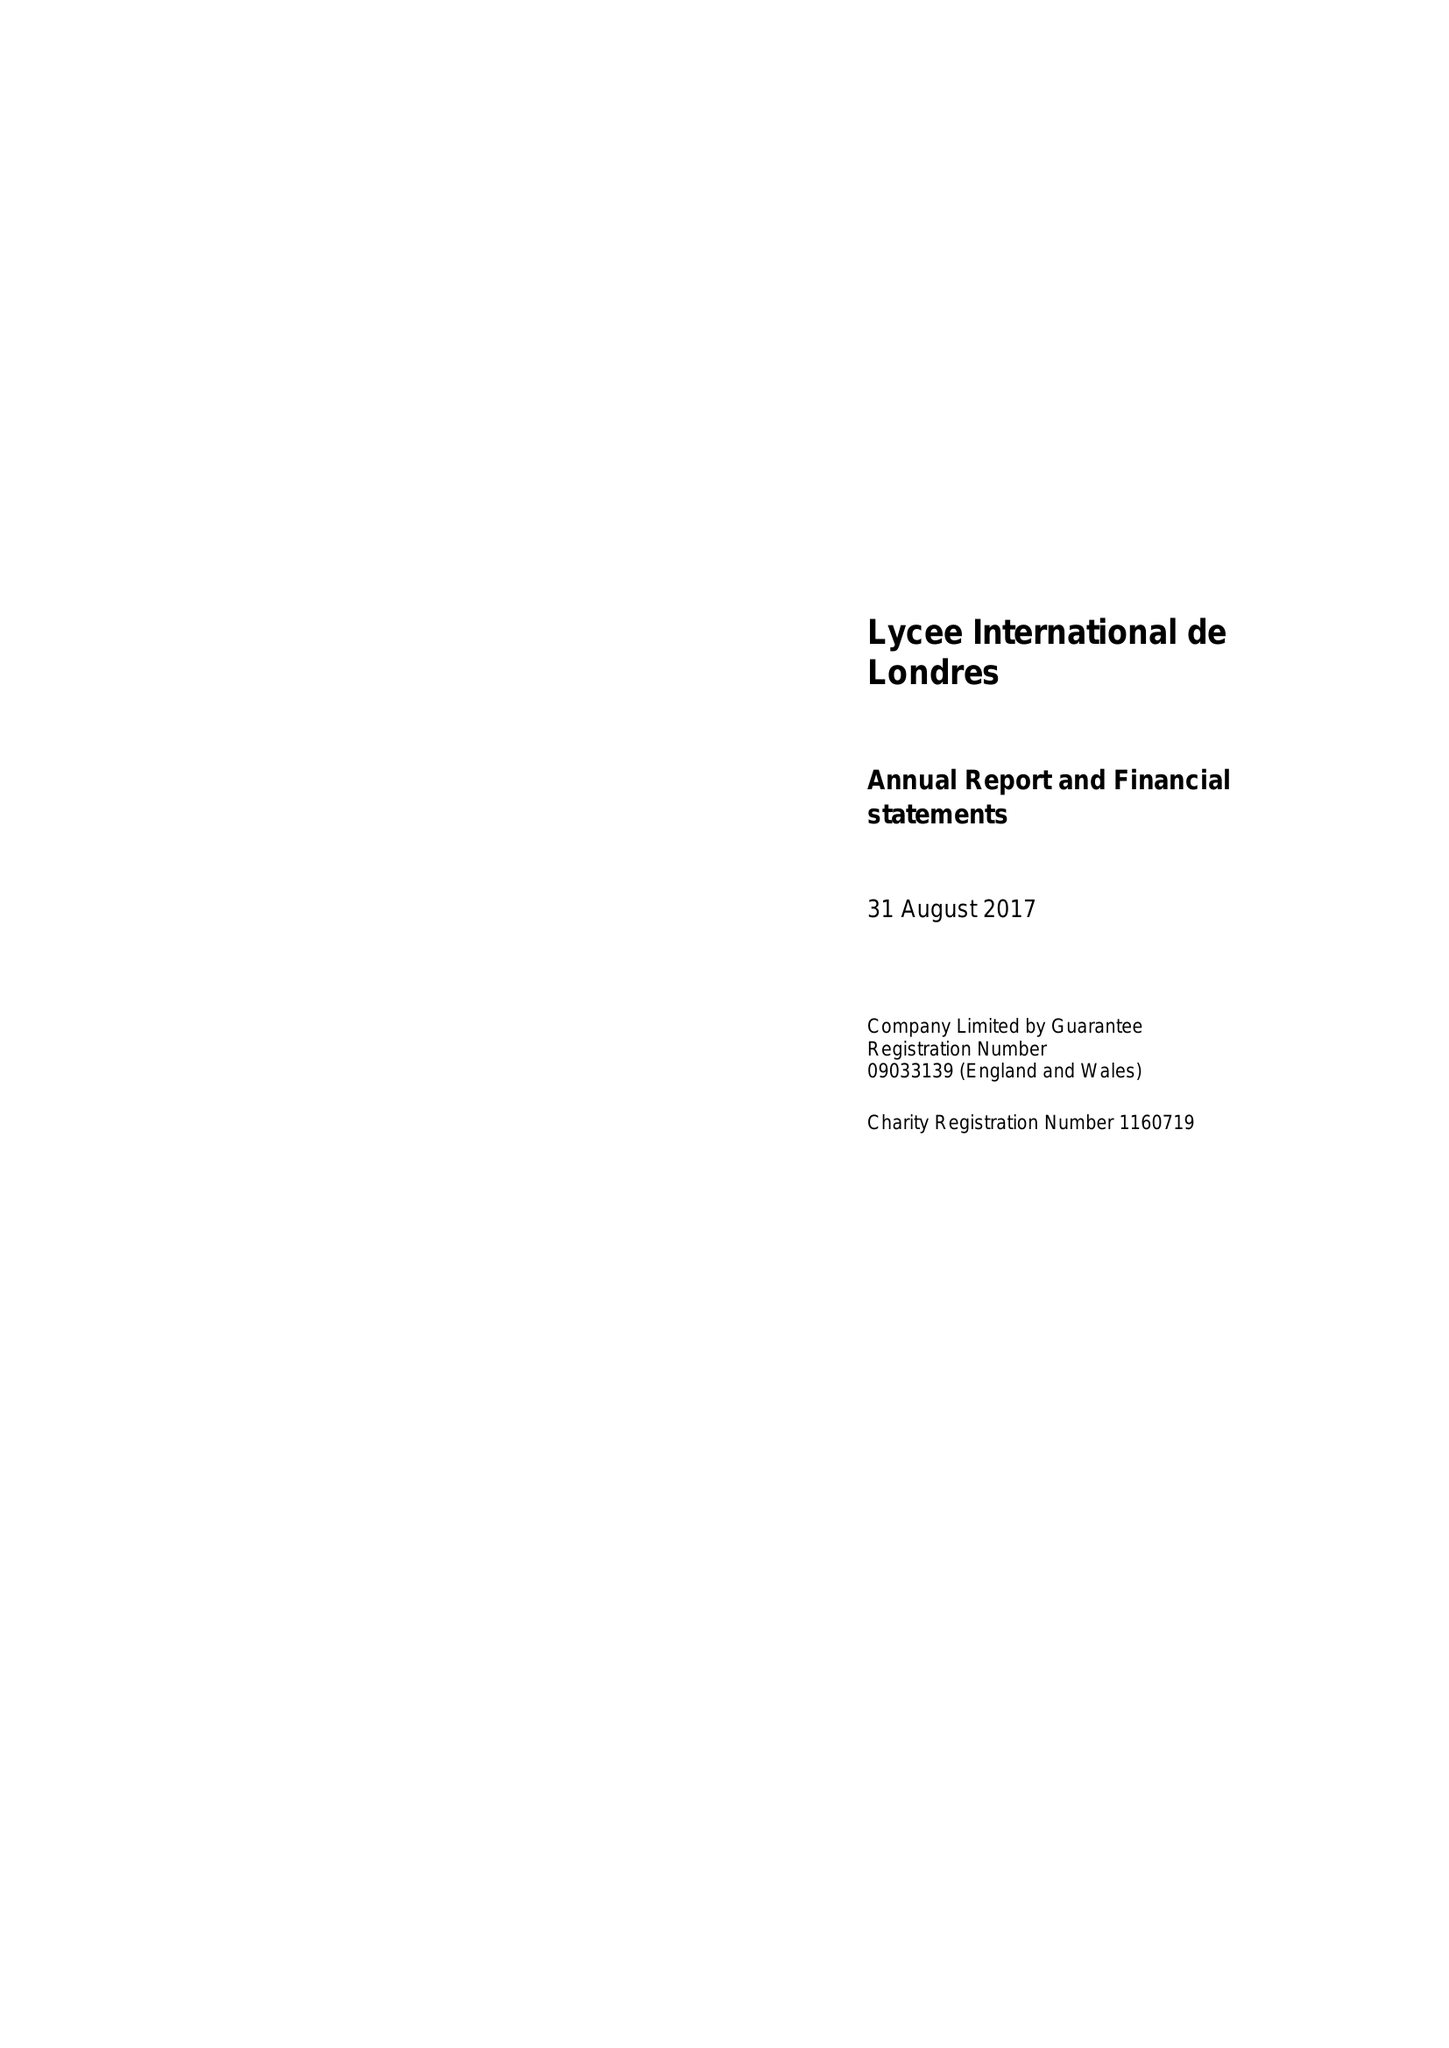What is the value for the charity_number?
Answer the question using a single word or phrase. 1160719 